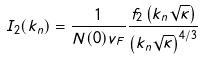Convert formula to latex. <formula><loc_0><loc_0><loc_500><loc_500>I _ { 2 } ( k _ { n } ) = \frac { 1 } { N ( 0 ) v _ { F } } \frac { f _ { 2 } \left ( k _ { n } \sqrt { \kappa } \right ) } { \left ( k _ { n } \sqrt { \kappa } \right ) ^ { 4 / 3 } }</formula> 